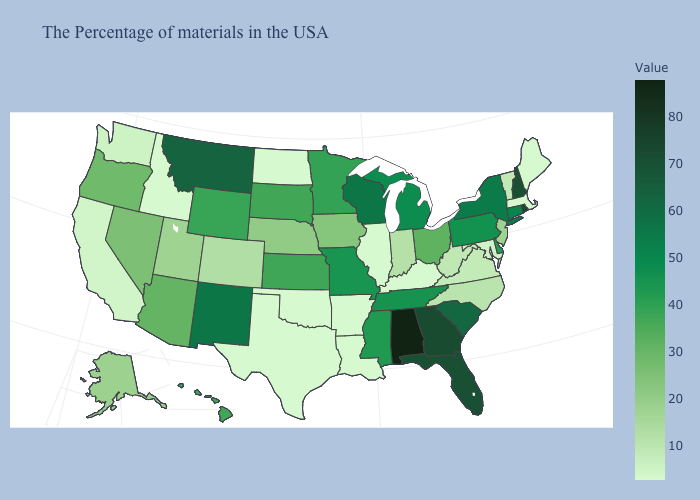Is the legend a continuous bar?
Short answer required. Yes. Among the states that border Indiana , does Kentucky have the lowest value?
Keep it brief. Yes. Is the legend a continuous bar?
Short answer required. Yes. Does Pennsylvania have the lowest value in the Northeast?
Be succinct. No. Does Idaho have the lowest value in the West?
Give a very brief answer. Yes. Which states have the lowest value in the South?
Keep it brief. Kentucky, Louisiana, Arkansas, Oklahoma, Texas. Which states have the lowest value in the USA?
Concise answer only. Maine, Massachusetts, Kentucky, Illinois, Louisiana, Arkansas, Oklahoma, Texas, North Dakota, Idaho. 